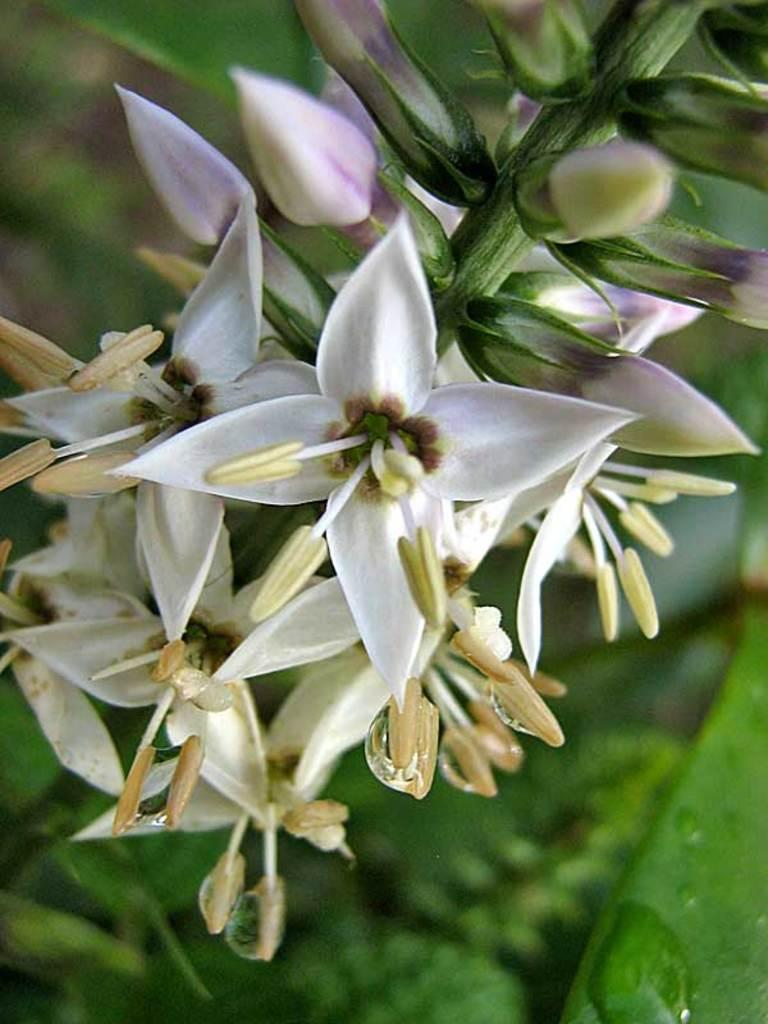What type of plants can be seen in the image? There are flowers in the image. Can you describe the structure of the flowers? The flowers have stems. What type of boot is hanging from the flowers in the image? There is no boot present in the image; it only features flowers with stems. 